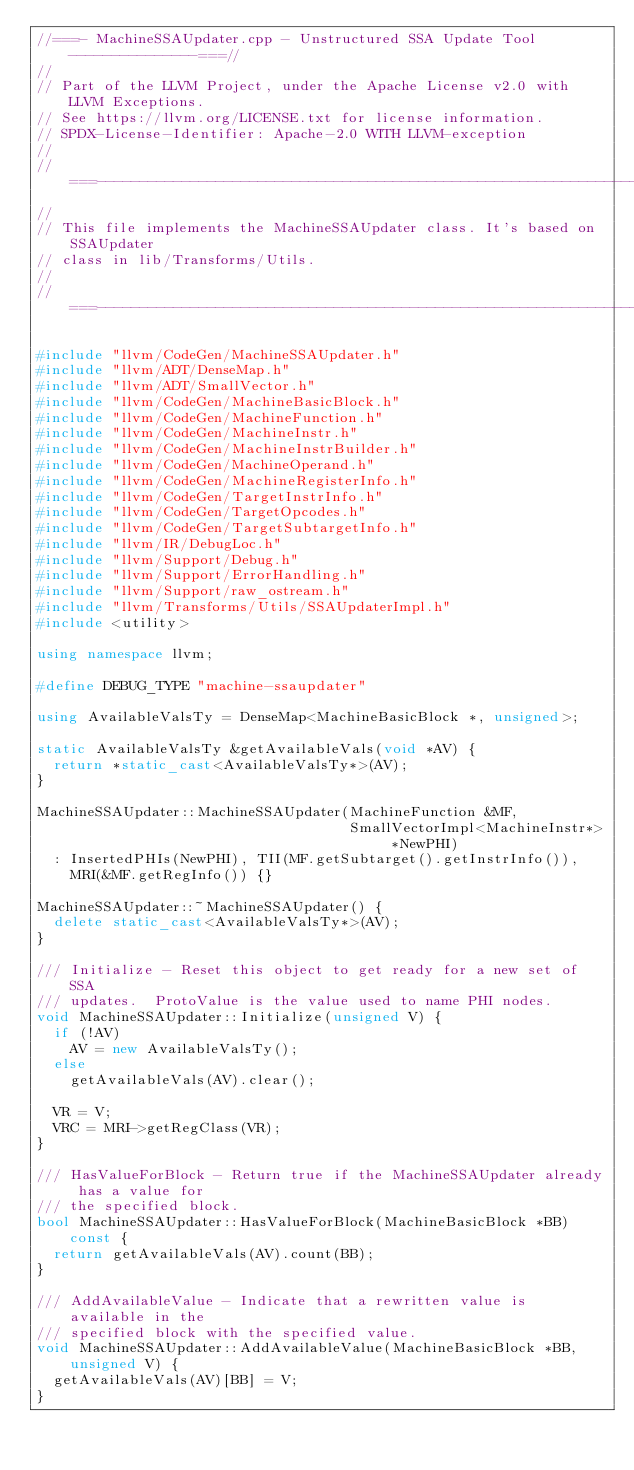<code> <loc_0><loc_0><loc_500><loc_500><_C++_>//===- MachineSSAUpdater.cpp - Unstructured SSA Update Tool ---------------===//
//
// Part of the LLVM Project, under the Apache License v2.0 with LLVM Exceptions.
// See https://llvm.org/LICENSE.txt for license information.
// SPDX-License-Identifier: Apache-2.0 WITH LLVM-exception
//
//===----------------------------------------------------------------------===//
//
// This file implements the MachineSSAUpdater class. It's based on SSAUpdater
// class in lib/Transforms/Utils.
//
//===----------------------------------------------------------------------===//

#include "llvm/CodeGen/MachineSSAUpdater.h"
#include "llvm/ADT/DenseMap.h"
#include "llvm/ADT/SmallVector.h"
#include "llvm/CodeGen/MachineBasicBlock.h"
#include "llvm/CodeGen/MachineFunction.h"
#include "llvm/CodeGen/MachineInstr.h"
#include "llvm/CodeGen/MachineInstrBuilder.h"
#include "llvm/CodeGen/MachineOperand.h"
#include "llvm/CodeGen/MachineRegisterInfo.h"
#include "llvm/CodeGen/TargetInstrInfo.h"
#include "llvm/CodeGen/TargetOpcodes.h"
#include "llvm/CodeGen/TargetSubtargetInfo.h"
#include "llvm/IR/DebugLoc.h"
#include "llvm/Support/Debug.h"
#include "llvm/Support/ErrorHandling.h"
#include "llvm/Support/raw_ostream.h"
#include "llvm/Transforms/Utils/SSAUpdaterImpl.h"
#include <utility>

using namespace llvm;

#define DEBUG_TYPE "machine-ssaupdater"

using AvailableValsTy = DenseMap<MachineBasicBlock *, unsigned>;

static AvailableValsTy &getAvailableVals(void *AV) {
  return *static_cast<AvailableValsTy*>(AV);
}

MachineSSAUpdater::MachineSSAUpdater(MachineFunction &MF,
                                     SmallVectorImpl<MachineInstr*> *NewPHI)
  : InsertedPHIs(NewPHI), TII(MF.getSubtarget().getInstrInfo()),
    MRI(&MF.getRegInfo()) {}

MachineSSAUpdater::~MachineSSAUpdater() {
  delete static_cast<AvailableValsTy*>(AV);
}

/// Initialize - Reset this object to get ready for a new set of SSA
/// updates.  ProtoValue is the value used to name PHI nodes.
void MachineSSAUpdater::Initialize(unsigned V) {
  if (!AV)
    AV = new AvailableValsTy();
  else
    getAvailableVals(AV).clear();

  VR = V;
  VRC = MRI->getRegClass(VR);
}

/// HasValueForBlock - Return true if the MachineSSAUpdater already has a value for
/// the specified block.
bool MachineSSAUpdater::HasValueForBlock(MachineBasicBlock *BB) const {
  return getAvailableVals(AV).count(BB);
}

/// AddAvailableValue - Indicate that a rewritten value is available in the
/// specified block with the specified value.
void MachineSSAUpdater::AddAvailableValue(MachineBasicBlock *BB, unsigned V) {
  getAvailableVals(AV)[BB] = V;
}
</code> 